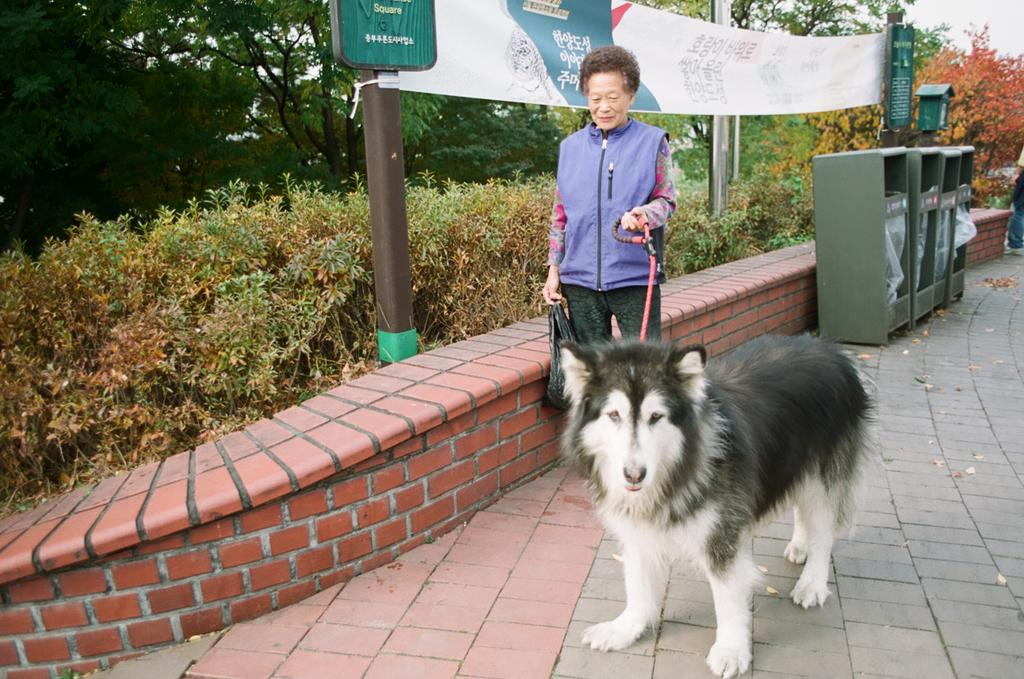Who is present in the image? There is a woman in the image. What is the woman holding? The woman is holding a dog belt. What is in front of the woman? There is a dog in front of the woman. What is behind the woman? There is a wall behind the woman. What can be seen in the distance in the image? There are poles, a banner, trees, and the sky visible in the background of the image. What type of mark can be seen on the dog's flesh in the image? There is no mark visible on the dog's flesh in the image. 